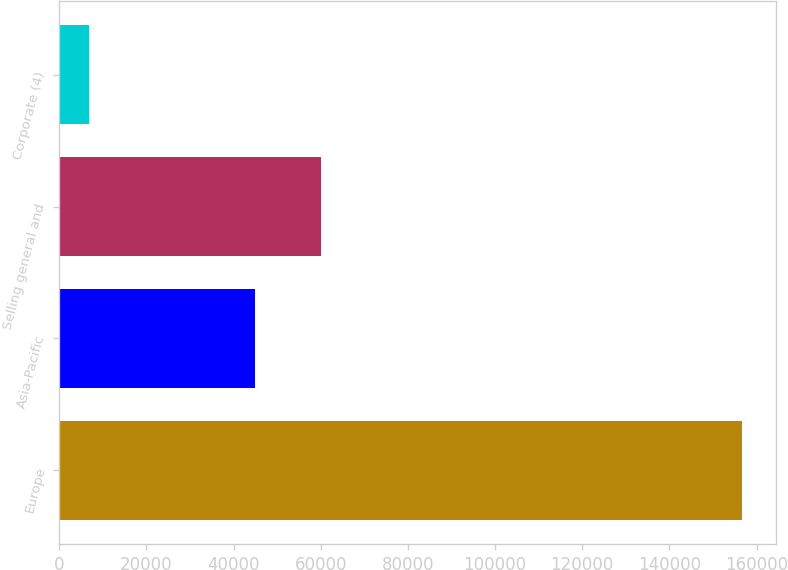<chart> <loc_0><loc_0><loc_500><loc_500><bar_chart><fcel>Europe<fcel>Asia-Pacific<fcel>Selling general and<fcel>Corporate (4)<nl><fcel>156594<fcel>44965<fcel>59943<fcel>6814<nl></chart> 